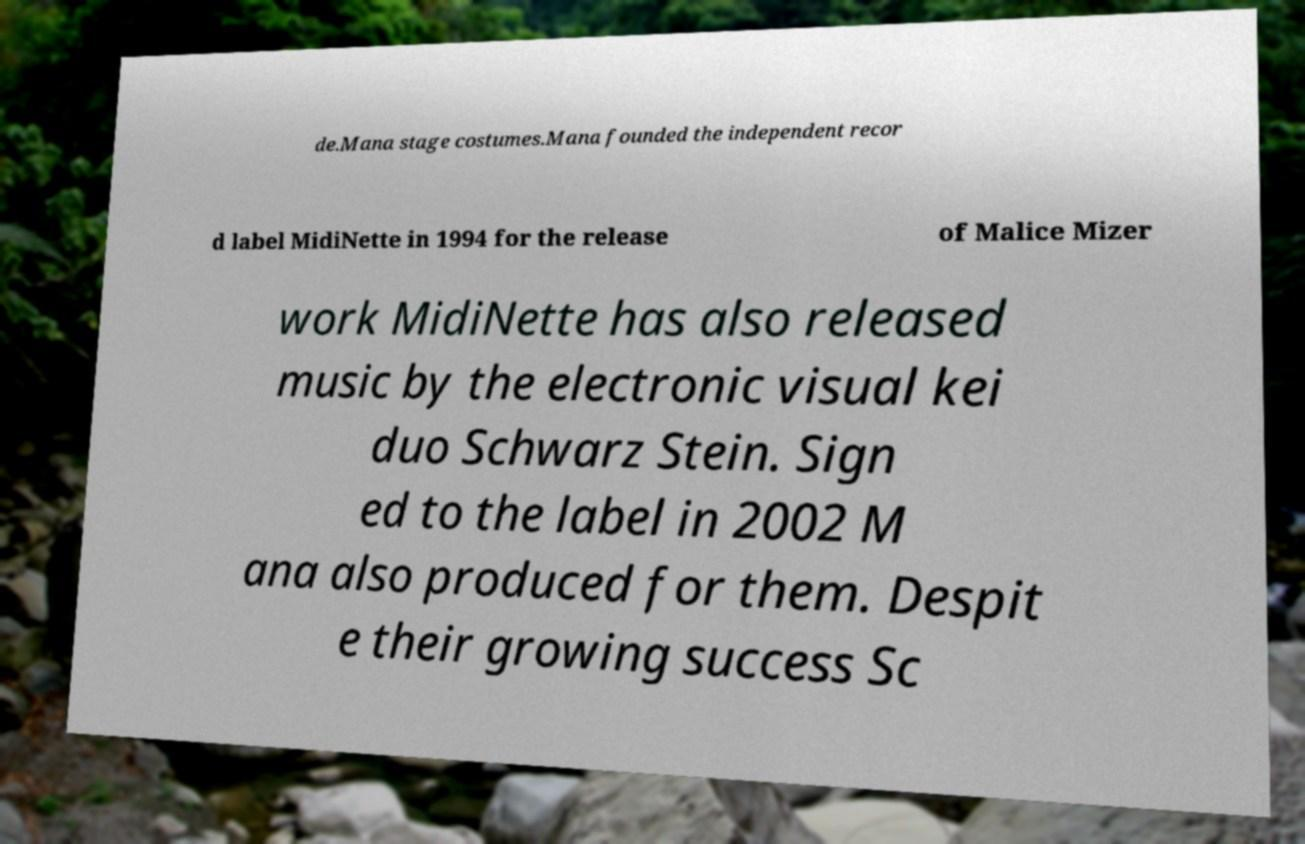Could you extract and type out the text from this image? de.Mana stage costumes.Mana founded the independent recor d label MidiNette in 1994 for the release of Malice Mizer work MidiNette has also released music by the electronic visual kei duo Schwarz Stein. Sign ed to the label in 2002 M ana also produced for them. Despit e their growing success Sc 